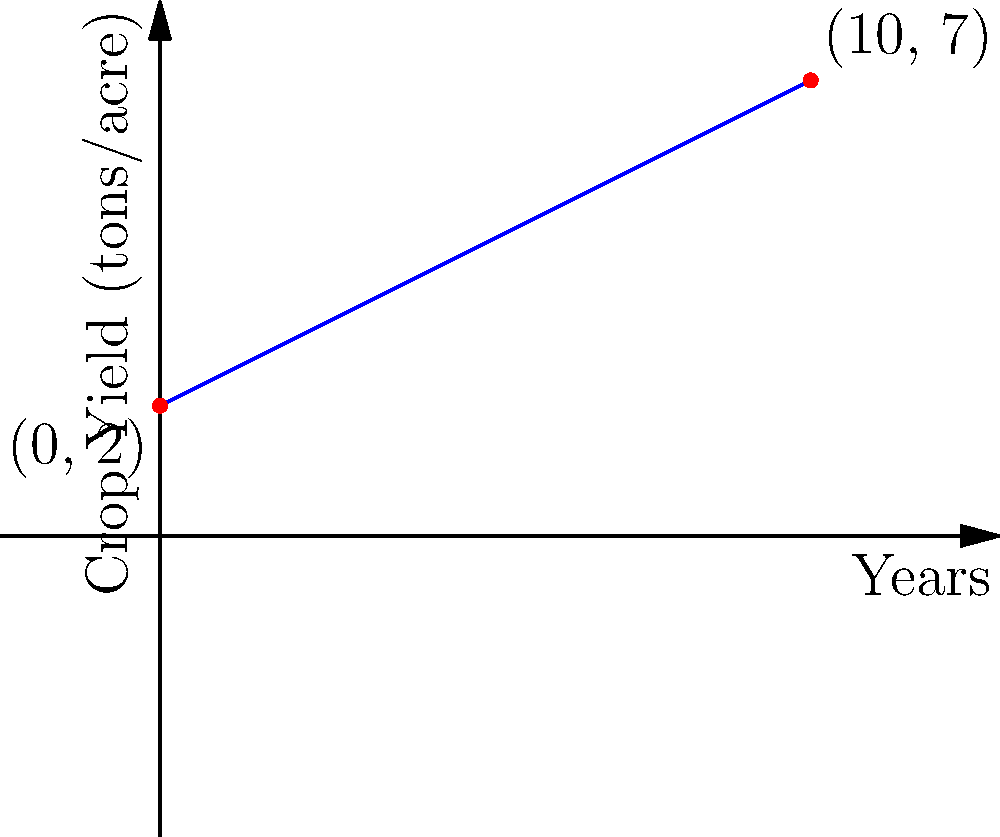Given the linear crop yield trend shown in the graph, what is the expected annual increase in crop yield, and what was the initial yield at year 0? To solve this problem, we need to analyze the slope and y-intercept of the linear trend:

1. Identify two points on the line:
   Point 1: $(0, 2)$
   Point 2: $(10, 7)$

2. Calculate the slope using the slope formula:
   $m = \frac{y_2 - y_1}{x_2 - x_1} = \frac{7 - 2}{10 - 0} = \frac{5}{10} = 0.5$

   The slope represents the annual increase in crop yield, which is 0.5 tons/acre per year.

3. Identify the y-intercept:
   The y-intercept is the point where the line crosses the y-axis, which is at $(0, 2)$.
   This represents the initial yield at year 0, which is 2 tons/acre.

4. The equation of the line can be written as:
   $y = 0.5x + 2$

   Where $y$ is the crop yield in tons/acre, and $x$ is the number of years.
Answer: 0.5 tons/acre per year; 2 tons/acre 